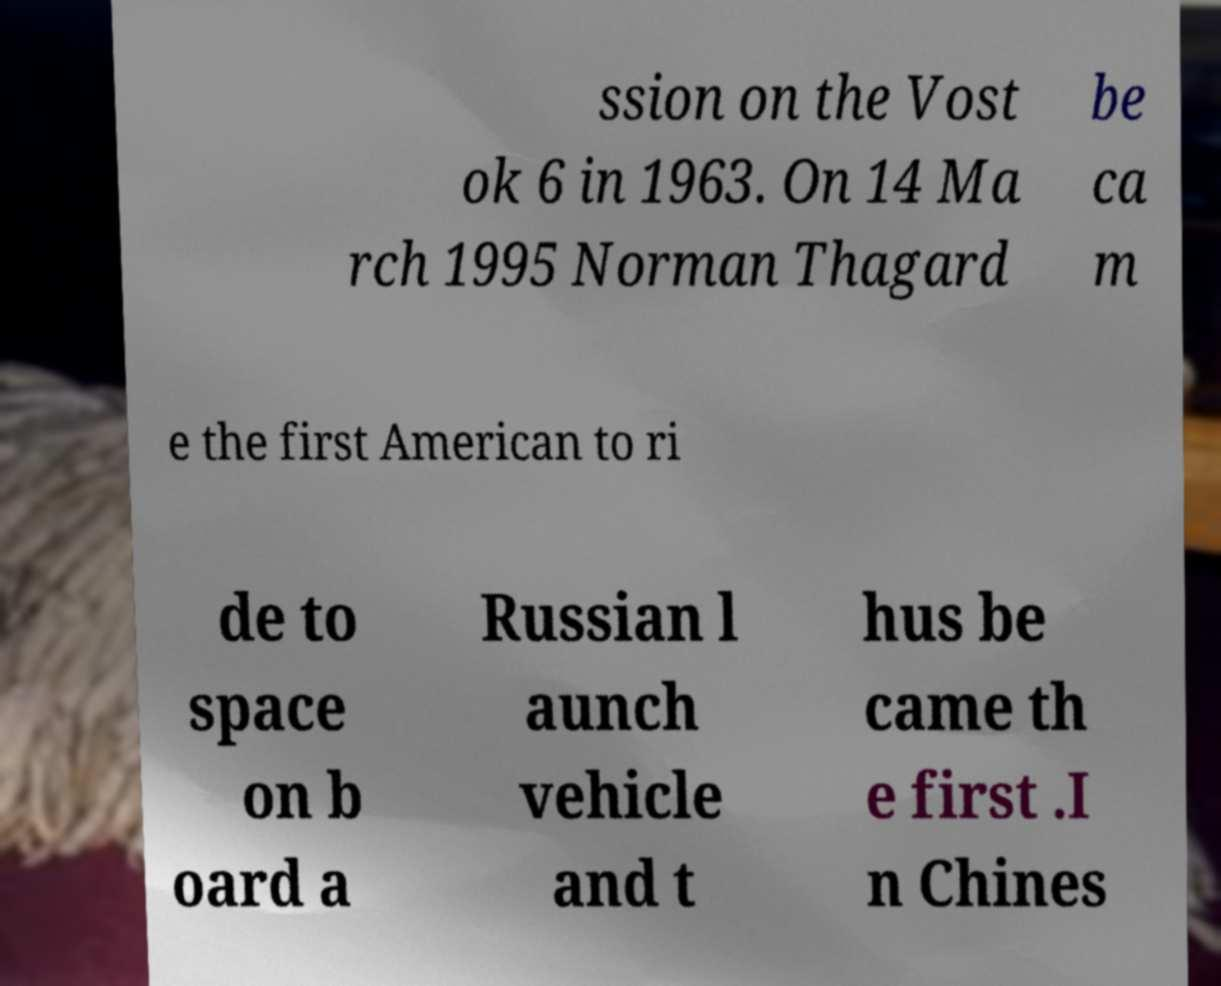There's text embedded in this image that I need extracted. Can you transcribe it verbatim? ssion on the Vost ok 6 in 1963. On 14 Ma rch 1995 Norman Thagard be ca m e the first American to ri de to space on b oard a Russian l aunch vehicle and t hus be came th e first .I n Chines 